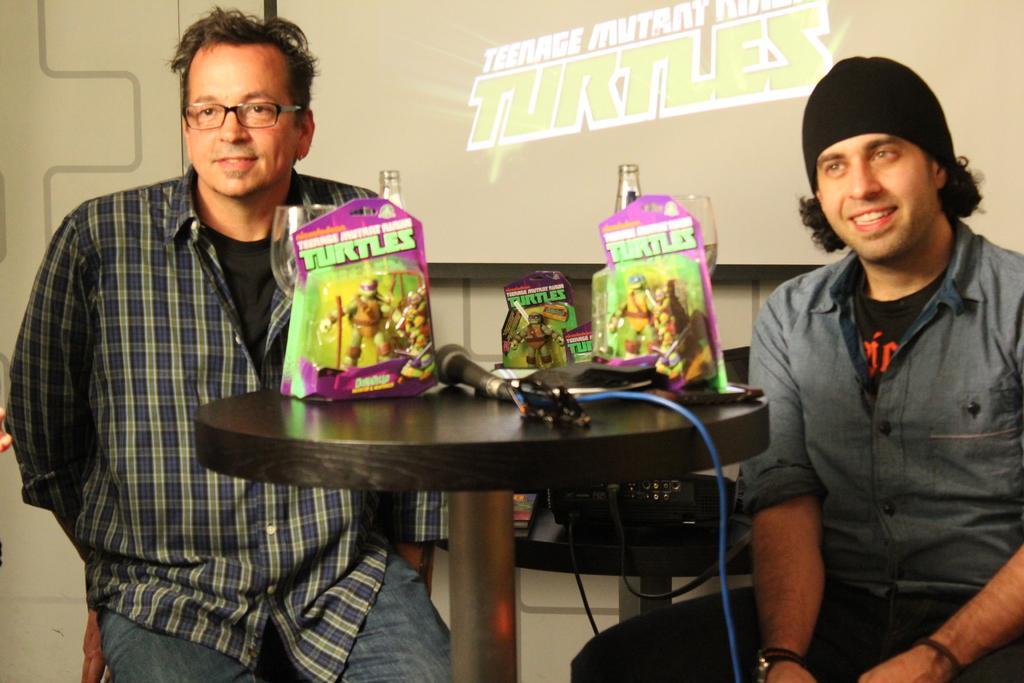Describe this image in one or two sentences. There are two men sitting together in front of a table when there are so many packets written turtle on it. 